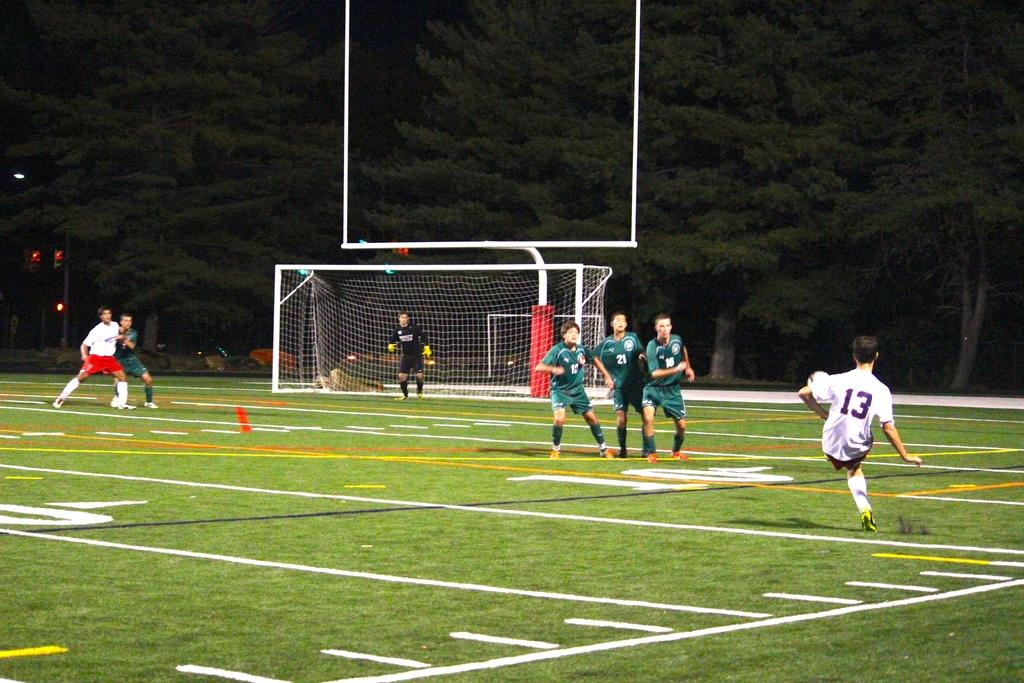<image>
Write a terse but informative summary of the picture. Player number 13 kicks the soccer ball towards player number 21 